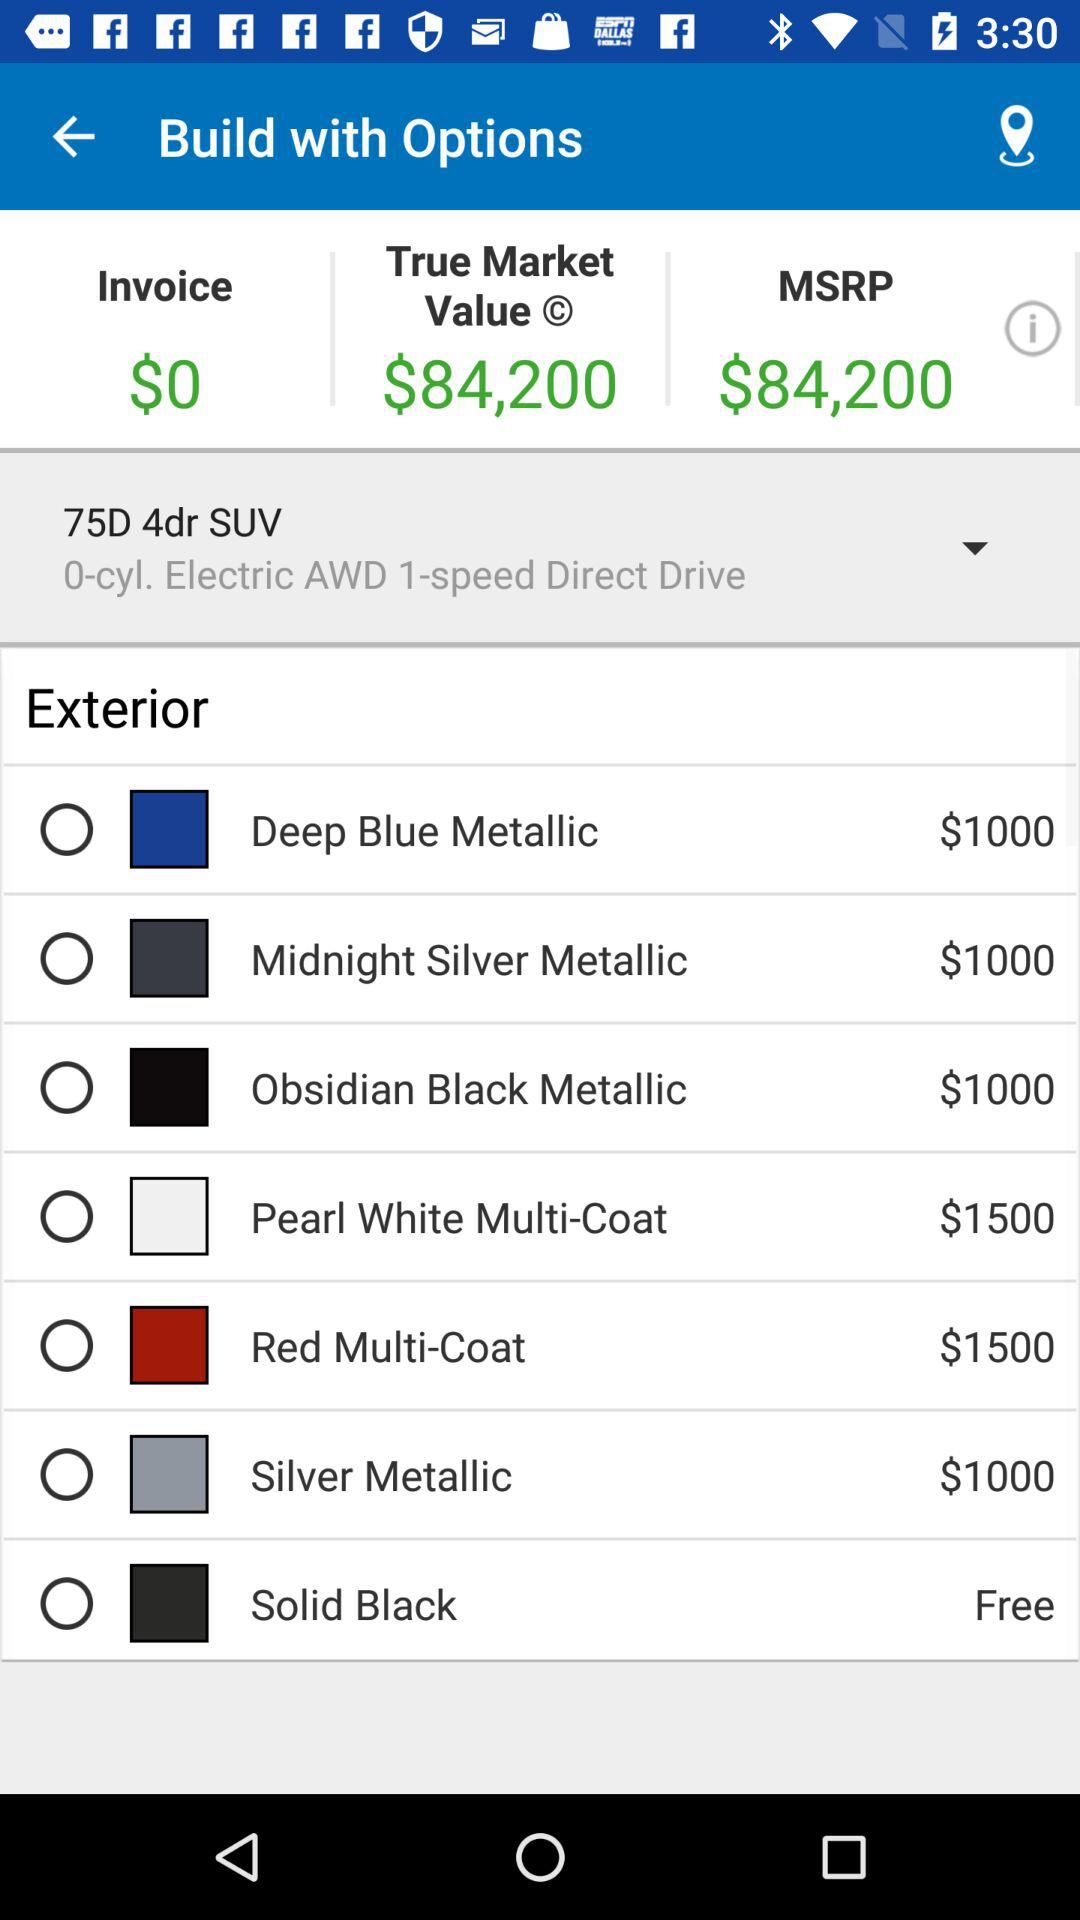What is the invoice amount? The invoice amount is $0. 